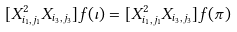<formula> <loc_0><loc_0><loc_500><loc_500>[ X _ { i _ { 1 } , j _ { 1 } } ^ { 2 } X _ { i _ { 3 } , j _ { 3 } } ] f ( \iota ) = [ X _ { i _ { 1 } , j _ { 1 } } ^ { 2 } X _ { i _ { 3 } , j _ { 3 } } ] f ( \pi )</formula> 